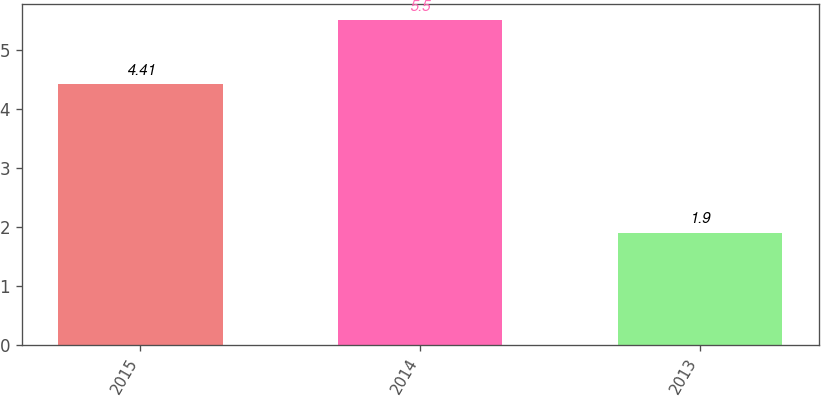Convert chart to OTSL. <chart><loc_0><loc_0><loc_500><loc_500><bar_chart><fcel>2015<fcel>2014<fcel>2013<nl><fcel>4.41<fcel>5.5<fcel>1.9<nl></chart> 